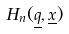Convert formula to latex. <formula><loc_0><loc_0><loc_500><loc_500>H _ { n } ( \underline { q } , \underline { x } )</formula> 